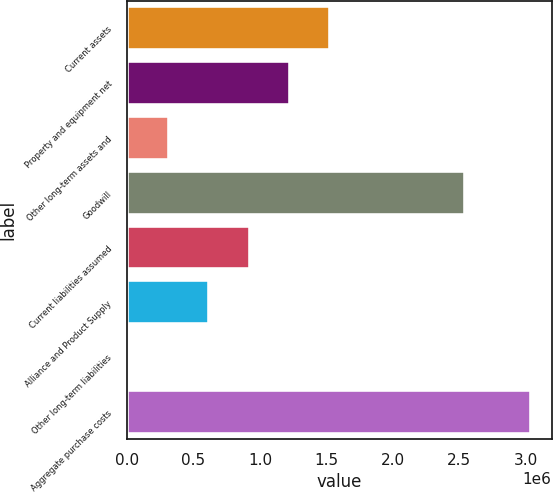Convert chart. <chart><loc_0><loc_0><loc_500><loc_500><bar_chart><fcel>Current assets<fcel>Property and equipment net<fcel>Other long-term assets and<fcel>Goodwill<fcel>Current liabilities assumed<fcel>Alliance and Product Supply<fcel>Other long-term liabilities<fcel>Aggregate purchase costs<nl><fcel>1.52907e+06<fcel>1.22618e+06<fcel>317528<fcel>2.54656e+06<fcel>923299<fcel>620413<fcel>14643<fcel>3.0435e+06<nl></chart> 